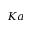<formula> <loc_0><loc_0><loc_500><loc_500>K a</formula> 